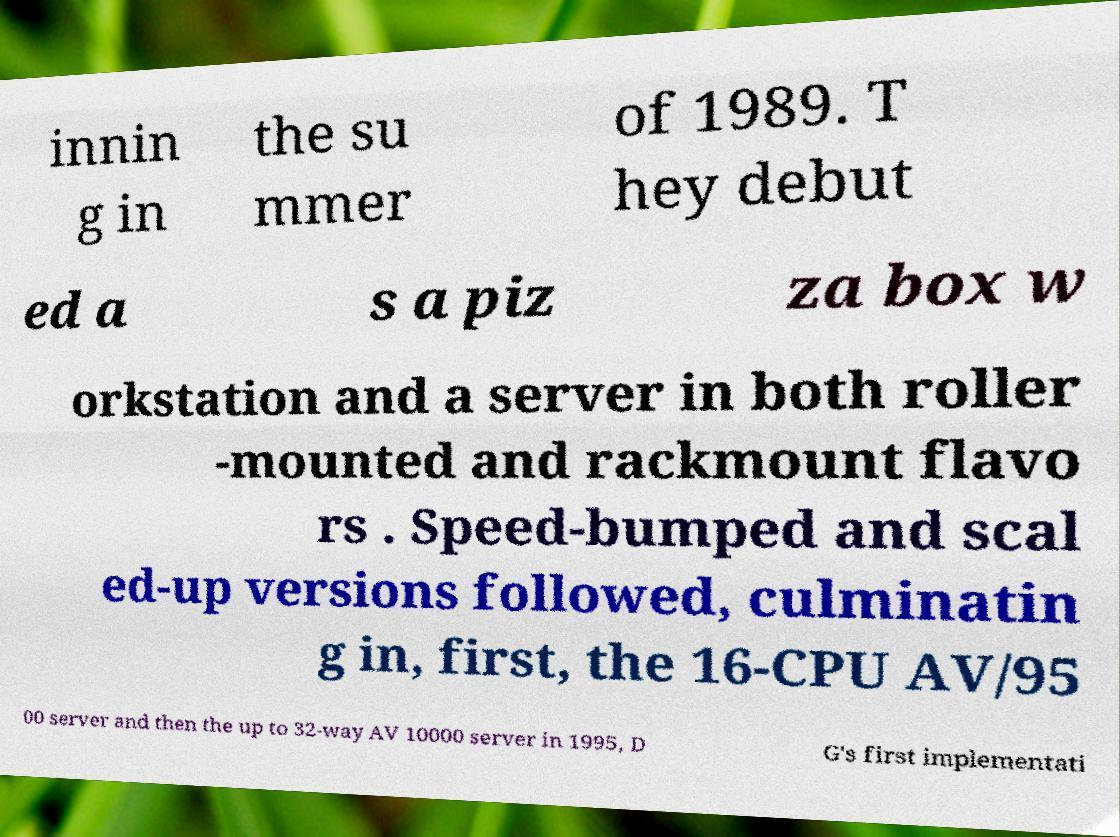Please read and relay the text visible in this image. What does it say? innin g in the su mmer of 1989. T hey debut ed a s a piz za box w orkstation and a server in both roller -mounted and rackmount flavo rs . Speed-bumped and scal ed-up versions followed, culminatin g in, first, the 16-CPU AV/95 00 server and then the up to 32-way AV 10000 server in 1995, D G's first implementati 